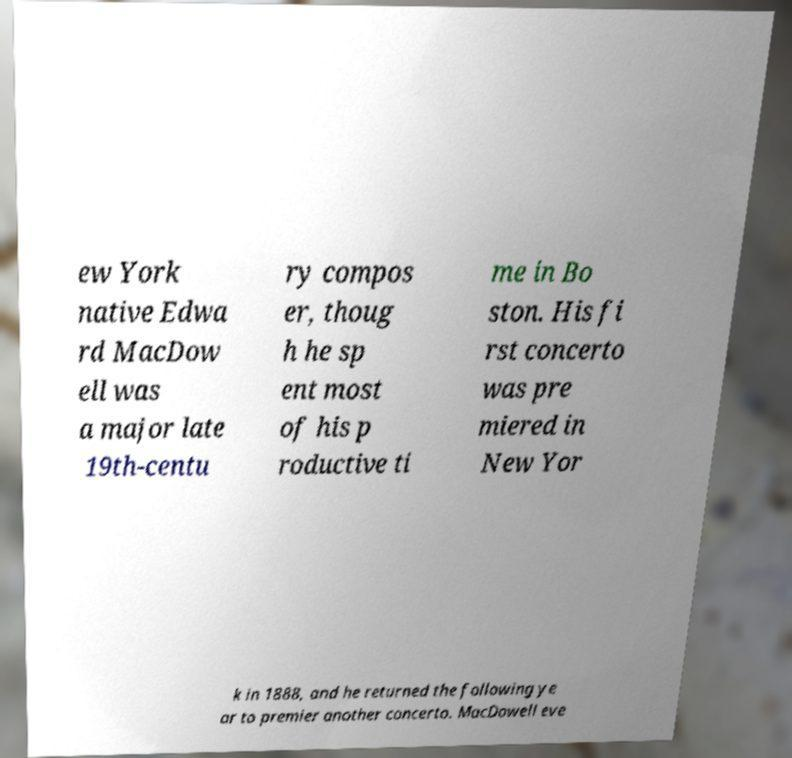Please identify and transcribe the text found in this image. ew York native Edwa rd MacDow ell was a major late 19th-centu ry compos er, thoug h he sp ent most of his p roductive ti me in Bo ston. His fi rst concerto was pre miered in New Yor k in 1888, and he returned the following ye ar to premier another concerto. MacDowell eve 